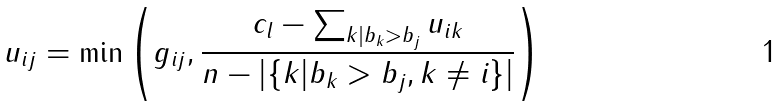Convert formula to latex. <formula><loc_0><loc_0><loc_500><loc_500>u _ { i j } = \min \left ( g _ { i j } , \frac { c _ { l } - \sum _ { k | b _ { k } > b _ { j } } u _ { i k } } { n - | \{ k | b _ { k } > b _ { j } , k \neq i \} | } \right )</formula> 